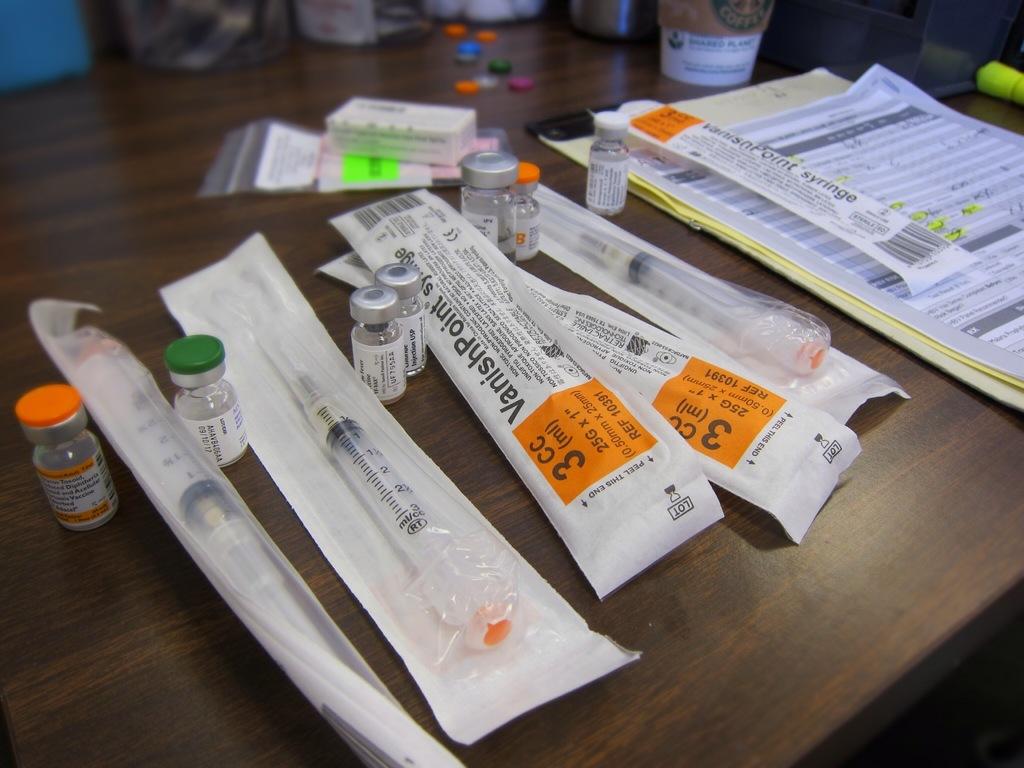How much ml this needle?
Ensure brevity in your answer.  3. What type of needles are these?
Give a very brief answer. Vanishpoint. 